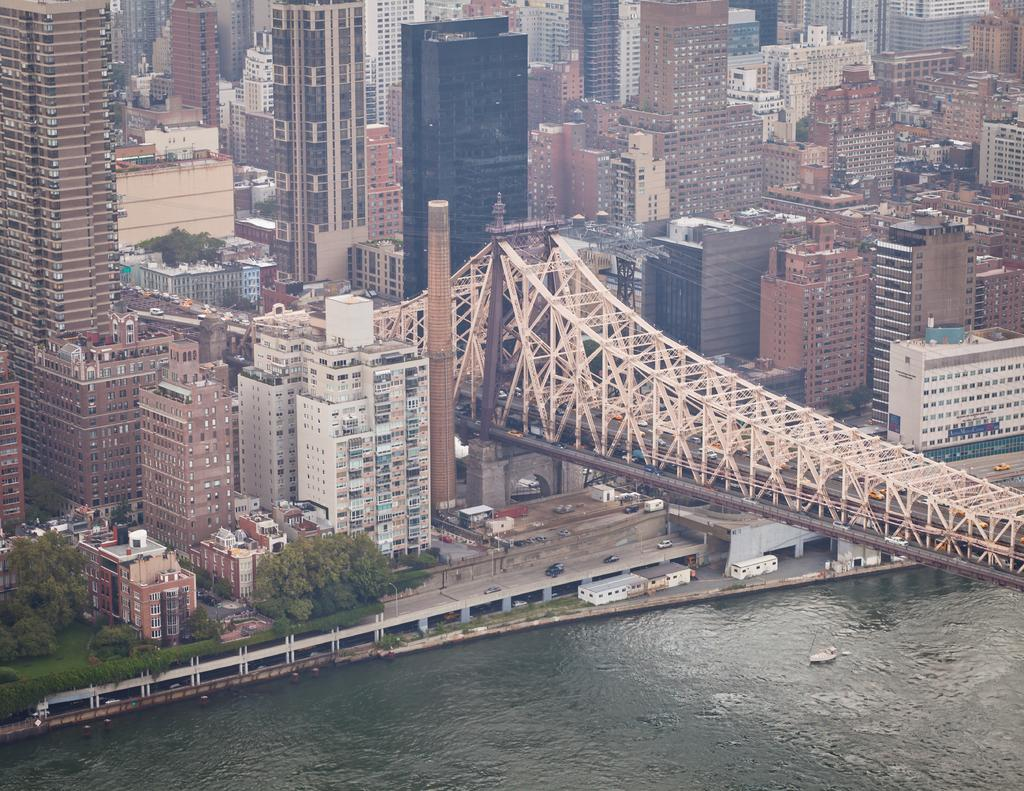What type of structure can be seen in the image? There is a bridge in the image. What else can be seen in the image besides the bridge? There are buildings and green color trees in the image. Is there any water visible in the image? Yes, there is water visible in the image. Can you see a giraffe eating from a plate near the water in the image? No, there is no giraffe or plate present in the image. 